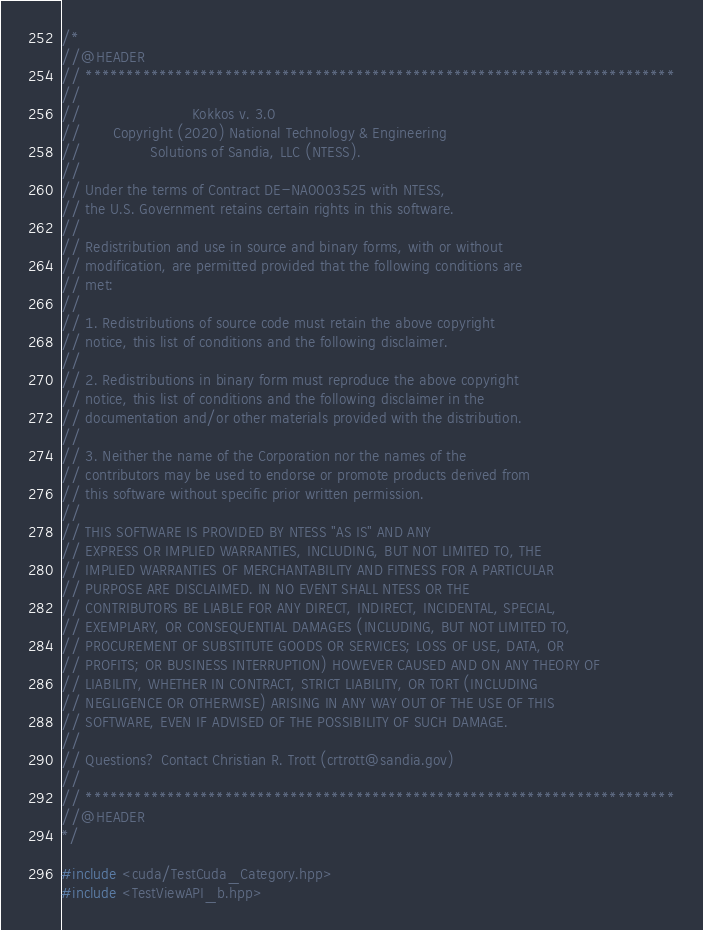<code> <loc_0><loc_0><loc_500><loc_500><_C++_>/*
//@HEADER
// ************************************************************************
//
//                        Kokkos v. 3.0
//       Copyright (2020) National Technology & Engineering
//               Solutions of Sandia, LLC (NTESS).
//
// Under the terms of Contract DE-NA0003525 with NTESS,
// the U.S. Government retains certain rights in this software.
//
// Redistribution and use in source and binary forms, with or without
// modification, are permitted provided that the following conditions are
// met:
//
// 1. Redistributions of source code must retain the above copyright
// notice, this list of conditions and the following disclaimer.
//
// 2. Redistributions in binary form must reproduce the above copyright
// notice, this list of conditions and the following disclaimer in the
// documentation and/or other materials provided with the distribution.
//
// 3. Neither the name of the Corporation nor the names of the
// contributors may be used to endorse or promote products derived from
// this software without specific prior written permission.
//
// THIS SOFTWARE IS PROVIDED BY NTESS "AS IS" AND ANY
// EXPRESS OR IMPLIED WARRANTIES, INCLUDING, BUT NOT LIMITED TO, THE
// IMPLIED WARRANTIES OF MERCHANTABILITY AND FITNESS FOR A PARTICULAR
// PURPOSE ARE DISCLAIMED. IN NO EVENT SHALL NTESS OR THE
// CONTRIBUTORS BE LIABLE FOR ANY DIRECT, INDIRECT, INCIDENTAL, SPECIAL,
// EXEMPLARY, OR CONSEQUENTIAL DAMAGES (INCLUDING, BUT NOT LIMITED TO,
// PROCUREMENT OF SUBSTITUTE GOODS OR SERVICES; LOSS OF USE, DATA, OR
// PROFITS; OR BUSINESS INTERRUPTION) HOWEVER CAUSED AND ON ANY THEORY OF
// LIABILITY, WHETHER IN CONTRACT, STRICT LIABILITY, OR TORT (INCLUDING
// NEGLIGENCE OR OTHERWISE) ARISING IN ANY WAY OUT OF THE USE OF THIS
// SOFTWARE, EVEN IF ADVISED OF THE POSSIBILITY OF SUCH DAMAGE.
//
// Questions? Contact Christian R. Trott (crtrott@sandia.gov)
//
// ************************************************************************
//@HEADER
*/

#include <cuda/TestCuda_Category.hpp>
#include <TestViewAPI_b.hpp>
</code> 